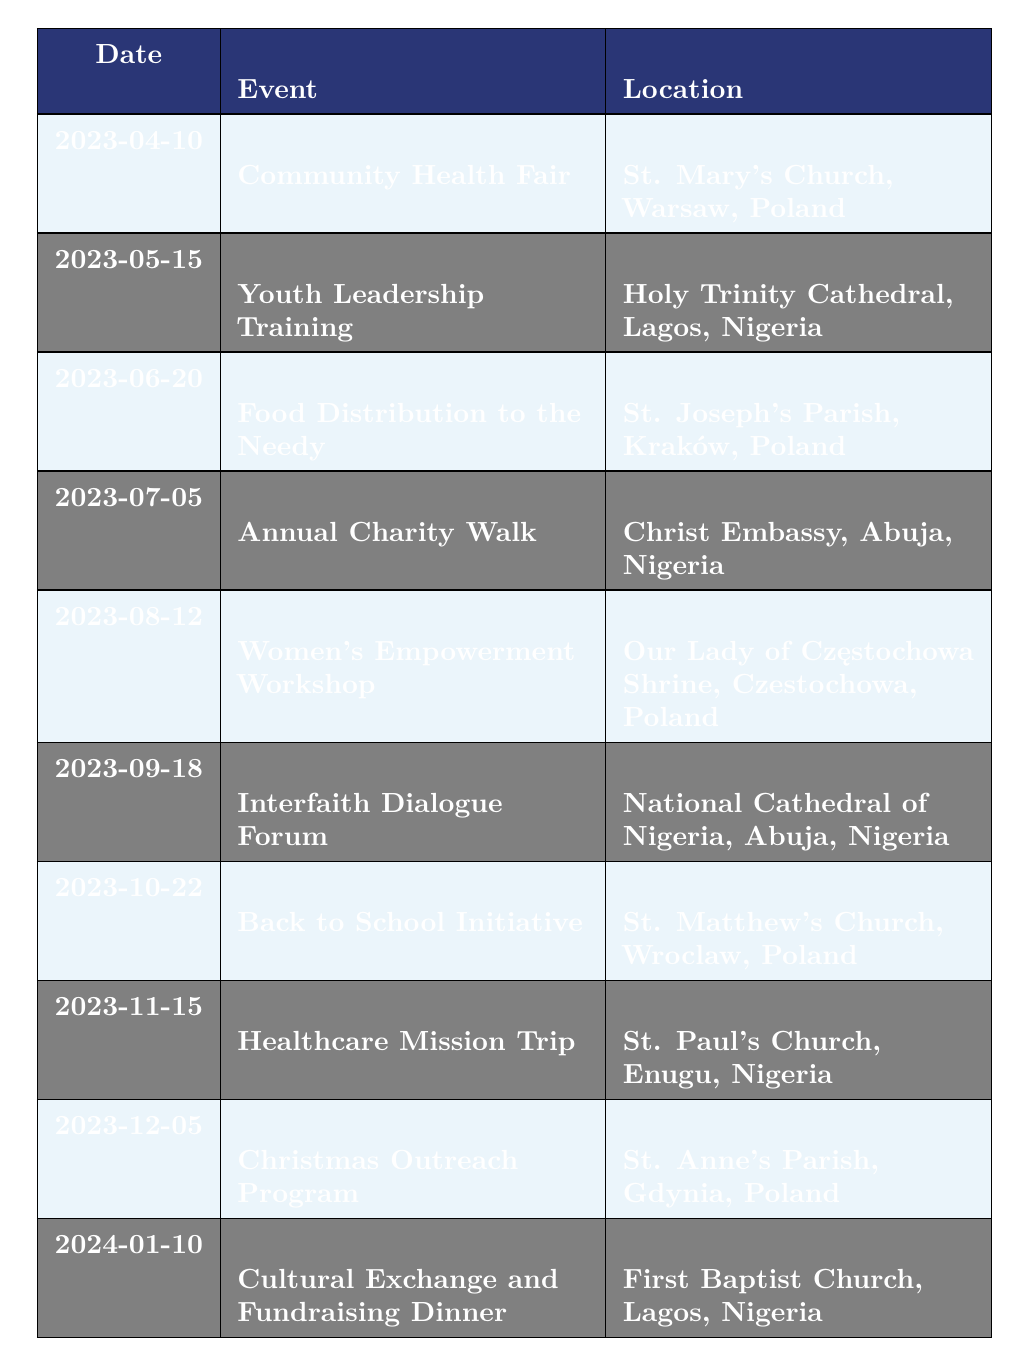What is the event scheduled on June 20, 2023? The table indicates that on June 20, 2023, the event listed is "Food Distribution to the Needy."
Answer: Food Distribution to the Needy Which country hosted the "Youth Leadership Training"? According to the table, "Youth Leadership Training" took place at Holy Trinity Cathedral in Lagos, Nigeria.
Answer: Nigeria How many events took place in Poland? By reviewing the table, we see the events listed for Poland are on April 10, June 20, August 12, October 22, and December 5. This gives a total of 5 events in Poland.
Answer: 5 Is there an event related to women's empowerment in the list? The table shows that on August 12, 2023, there is a "Women's Empowerment Workshop" listed. Therefore, the statement is true.
Answer: Yes What is the description of the "Back to School Initiative"? The description for the "Back to School Initiative," scheduled for October 22, 2023, is "Collection of school supplies and uniforms for children in need, alongside a community gathering."
Answer: Collection of school supplies and uniforms for children in need, alongside a community gathering Which event had the earliest date? By examining the dates in the table, the earliest event is "Community Health Fair," taking place on April 10, 2023.
Answer: Community Health Fair How many events occur in Nigeria after August 2023? The events in Nigeria listed after August 2023 are "Healthcare Mission Trip" on November 15, 2023, and "Cultural Exchange and Fundraising Dinner" on January 10, 2024. Therefore, there are 2 events in Nigeria after August 2023.
Answer: 2 What is the total number of events listed in the timetable? The table contains a total of 10 rows of events, each representing a separate activity or program. Therefore, the total number of events is 10.
Answer: 10 What is the event on November 15, 2023, and where will it take place? On November 15, 2023, the event is "Healthcare Mission Trip" occurring at St. Paul's Church in Enugu, Nigeria.
Answer: Healthcare Mission Trip at St. Paul's Church, Enugu, Nigeria 